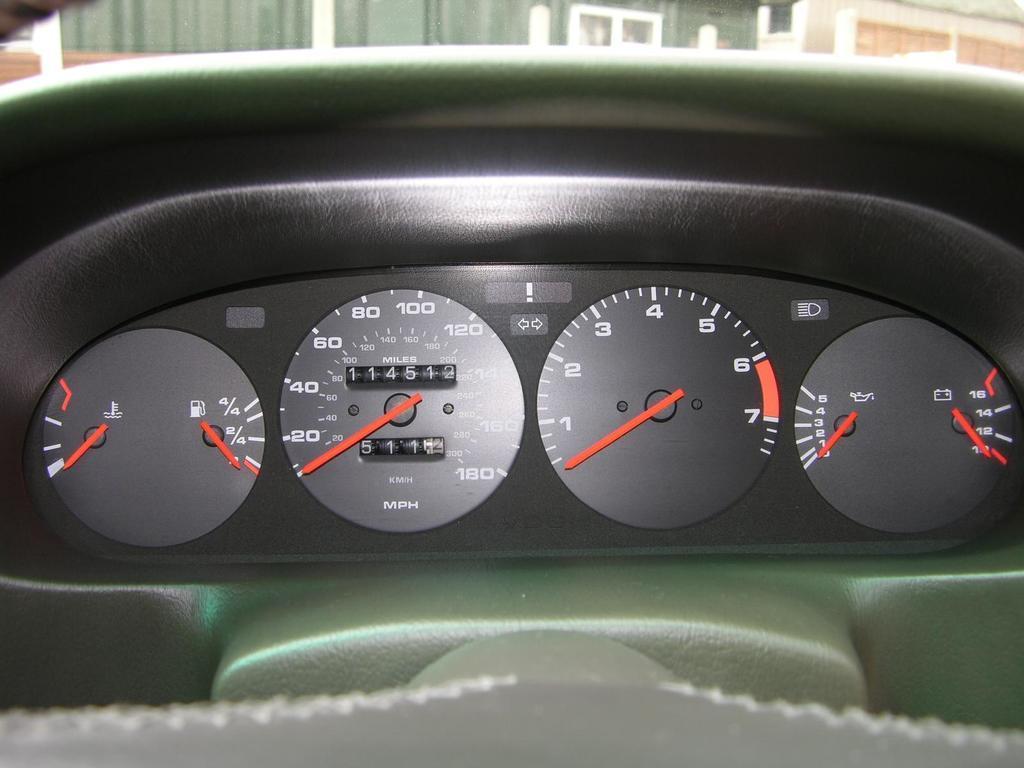Please provide a concise description of this image. In this image in the front there are meters. In the background there are objects which are green and white in colour and there are red colour objects in the meter. 